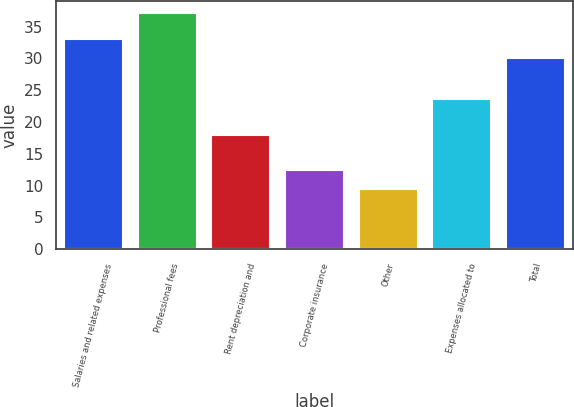Convert chart to OTSL. <chart><loc_0><loc_0><loc_500><loc_500><bar_chart><fcel>Salaries and related expenses<fcel>Professional fees<fcel>Rent depreciation and<fcel>Corporate insurance<fcel>Other<fcel>Expenses allocated to<fcel>Total<nl><fcel>33.1<fcel>37.2<fcel>18<fcel>12.5<fcel>9.5<fcel>23.6<fcel>30.1<nl></chart> 